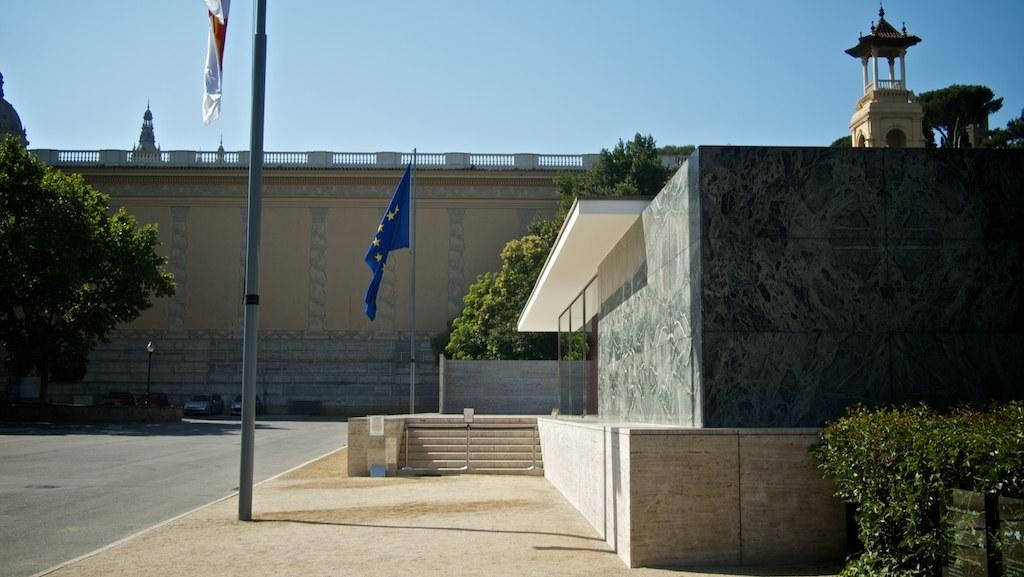In one or two sentences, can you explain what this image depicts? To the bottom of the image there is a footpath with two flag poles with flags. And to the right corner there is a building with walls and steps. To the right bottom corner there is a plant. And to the left side corner there is a tree. Beside the tree on the road there are few cars. In the background there is a big wall and to the right top corner there is a tower. To the top of the image there is a sky. 